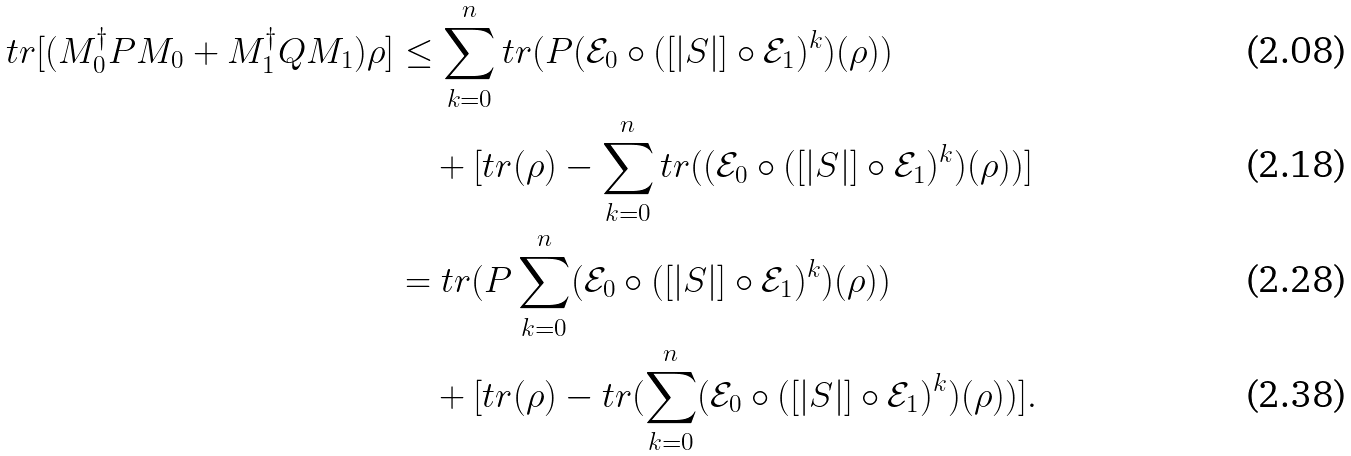<formula> <loc_0><loc_0><loc_500><loc_500>t r [ ( M _ { 0 } ^ { \dag } P M _ { 0 } + M _ { 1 } ^ { \dag } Q M _ { 1 } ) \rho ] & \leq \sum _ { k = 0 } ^ { n } t r ( P ( \mathcal { E } _ { 0 } \circ ( [ | S | ] \circ \mathcal { E } _ { 1 } ) ^ { k } ) ( \rho ) ) \\ & \quad + [ t r ( \rho ) - \sum _ { k = 0 } ^ { n } t r ( ( \mathcal { E } _ { 0 } \circ ( [ | S | ] \circ \mathcal { E } _ { 1 } ) ^ { k } ) ( \rho ) ) ] \\ & = t r ( P \sum _ { k = 0 } ^ { n } ( \mathcal { E } _ { 0 } \circ ( [ | S | ] \circ \mathcal { E } _ { 1 } ) ^ { k } ) ( \rho ) ) \\ & \quad + [ t r ( \rho ) - t r ( \sum _ { k = 0 } ^ { n } ( \mathcal { E } _ { 0 } \circ ( [ | S | ] \circ \mathcal { E } _ { 1 } ) ^ { k } ) ( \rho ) ) ] .</formula> 